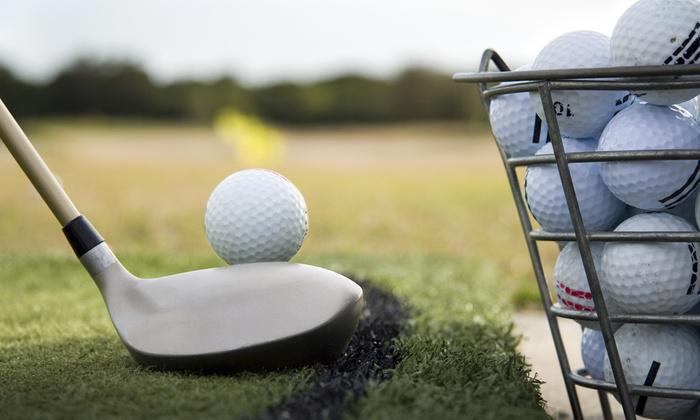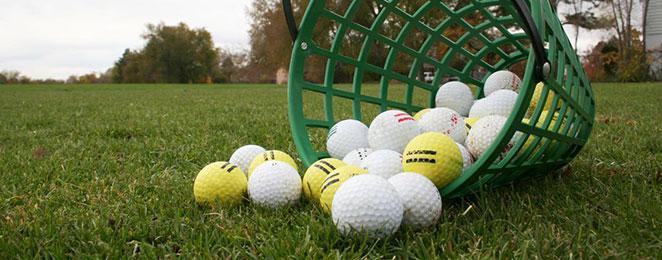The first image is the image on the left, the second image is the image on the right. Considering the images on both sides, is "In 1 of the images, at least 1 bucket is tipped over." valid? Answer yes or no. Yes. The first image is the image on the left, the second image is the image on the right. Analyze the images presented: Is the assertion "There is a red golf ball in the pile." valid? Answer yes or no. No. 